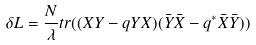Convert formula to latex. <formula><loc_0><loc_0><loc_500><loc_500>\delta L = \frac { N } { \lambda } t r ( ( X Y - q Y X ) ( \bar { Y } \bar { X } - q ^ { * } \bar { X } \bar { Y } ) )</formula> 